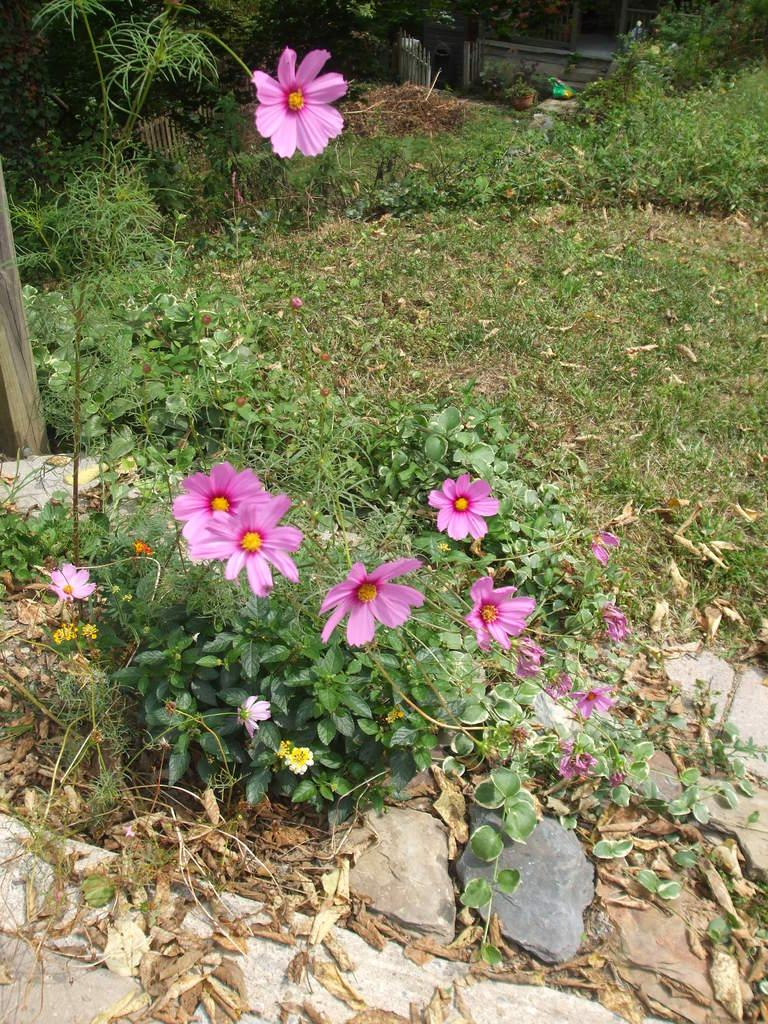What type of plants can be seen in the image? There are plants with flowers in the image. What is located at the front of the image? There are stones at the front of the image. What type of vegetation is visible on the surface? There is grass visible on the surface. What structure can be seen at the back side of the image? There is a gate at the back side of the image. What company is responsible for maintaining the grandmother's garden in the image? There is no mention of a company or a grandmother in the image, and therefore no such information can be provided. 